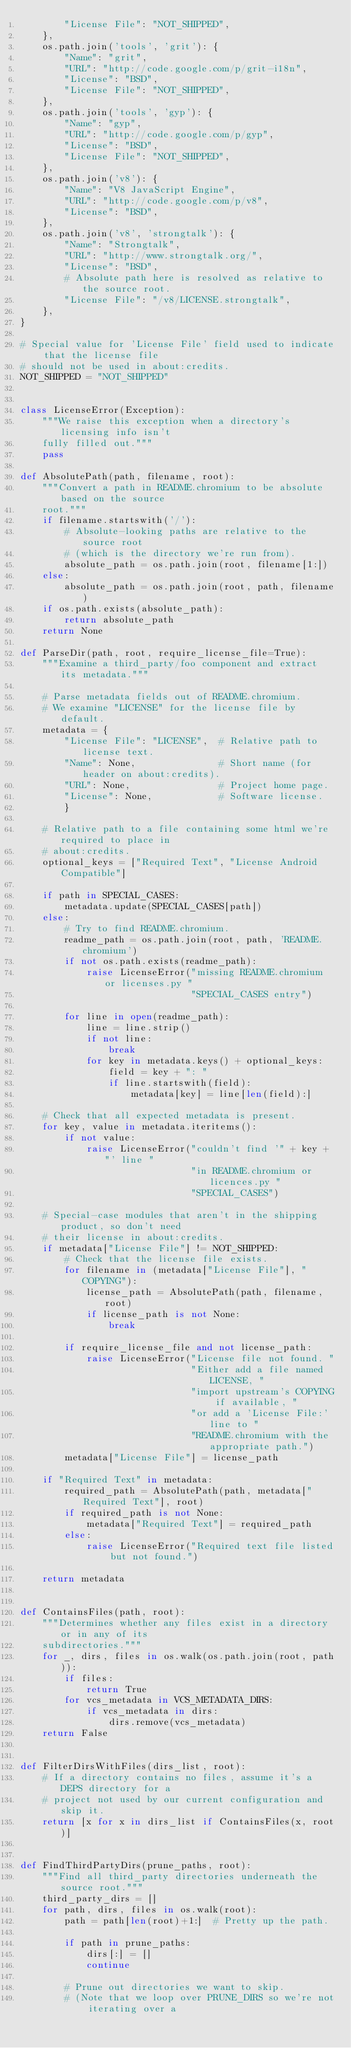Convert code to text. <code><loc_0><loc_0><loc_500><loc_500><_Python_>        "License File": "NOT_SHIPPED",
    },
    os.path.join('tools', 'grit'): {
        "Name": "grit",
        "URL": "http://code.google.com/p/grit-i18n",
        "License": "BSD",
        "License File": "NOT_SHIPPED",
    },
    os.path.join('tools', 'gyp'): {
        "Name": "gyp",
        "URL": "http://code.google.com/p/gyp",
        "License": "BSD",
        "License File": "NOT_SHIPPED",
    },
    os.path.join('v8'): {
        "Name": "V8 JavaScript Engine",
        "URL": "http://code.google.com/p/v8",
        "License": "BSD",
    },
    os.path.join('v8', 'strongtalk'): {
        "Name": "Strongtalk",
        "URL": "http://www.strongtalk.org/",
        "License": "BSD",
        # Absolute path here is resolved as relative to the source root.
        "License File": "/v8/LICENSE.strongtalk",
    },
}

# Special value for 'License File' field used to indicate that the license file
# should not be used in about:credits.
NOT_SHIPPED = "NOT_SHIPPED"


class LicenseError(Exception):
    """We raise this exception when a directory's licensing info isn't
    fully filled out."""
    pass

def AbsolutePath(path, filename, root):
    """Convert a path in README.chromium to be absolute based on the source
    root."""
    if filename.startswith('/'):
        # Absolute-looking paths are relative to the source root
        # (which is the directory we're run from).
        absolute_path = os.path.join(root, filename[1:])
    else:
        absolute_path = os.path.join(root, path, filename)
    if os.path.exists(absolute_path):
        return absolute_path
    return None

def ParseDir(path, root, require_license_file=True):
    """Examine a third_party/foo component and extract its metadata."""

    # Parse metadata fields out of README.chromium.
    # We examine "LICENSE" for the license file by default.
    metadata = {
        "License File": "LICENSE",  # Relative path to license text.
        "Name": None,               # Short name (for header on about:credits).
        "URL": None,                # Project home page.
        "License": None,            # Software license.
        }

    # Relative path to a file containing some html we're required to place in
    # about:credits.
    optional_keys = ["Required Text", "License Android Compatible"]

    if path in SPECIAL_CASES:
        metadata.update(SPECIAL_CASES[path])
    else:
        # Try to find README.chromium.
        readme_path = os.path.join(root, path, 'README.chromium')
        if not os.path.exists(readme_path):
            raise LicenseError("missing README.chromium or licenses.py "
                               "SPECIAL_CASES entry")

        for line in open(readme_path):
            line = line.strip()
            if not line:
                break
            for key in metadata.keys() + optional_keys:
                field = key + ": "
                if line.startswith(field):
                    metadata[key] = line[len(field):]

    # Check that all expected metadata is present.
    for key, value in metadata.iteritems():
        if not value:
            raise LicenseError("couldn't find '" + key + "' line "
                               "in README.chromium or licences.py "
                               "SPECIAL_CASES")

    # Special-case modules that aren't in the shipping product, so don't need
    # their license in about:credits.
    if metadata["License File"] != NOT_SHIPPED:
        # Check that the license file exists.
        for filename in (metadata["License File"], "COPYING"):
            license_path = AbsolutePath(path, filename, root)
            if license_path is not None:
                break

        if require_license_file and not license_path:
            raise LicenseError("License file not found. "
                               "Either add a file named LICENSE, "
                               "import upstream's COPYING if available, "
                               "or add a 'License File:' line to "
                               "README.chromium with the appropriate path.")
        metadata["License File"] = license_path

    if "Required Text" in metadata:
        required_path = AbsolutePath(path, metadata["Required Text"], root)
        if required_path is not None:
            metadata["Required Text"] = required_path
        else:
            raise LicenseError("Required text file listed but not found.")

    return metadata


def ContainsFiles(path, root):
    """Determines whether any files exist in a directory or in any of its
    subdirectories."""
    for _, dirs, files in os.walk(os.path.join(root, path)):
        if files:
            return True
        for vcs_metadata in VCS_METADATA_DIRS:
            if vcs_metadata in dirs:
                dirs.remove(vcs_metadata)
    return False


def FilterDirsWithFiles(dirs_list, root):
    # If a directory contains no files, assume it's a DEPS directory for a
    # project not used by our current configuration and skip it.
    return [x for x in dirs_list if ContainsFiles(x, root)]


def FindThirdPartyDirs(prune_paths, root):
    """Find all third_party directories underneath the source root."""
    third_party_dirs = []
    for path, dirs, files in os.walk(root):
        path = path[len(root)+1:]  # Pretty up the path.

        if path in prune_paths:
            dirs[:] = []
            continue

        # Prune out directories we want to skip.
        # (Note that we loop over PRUNE_DIRS so we're not iterating over a</code> 